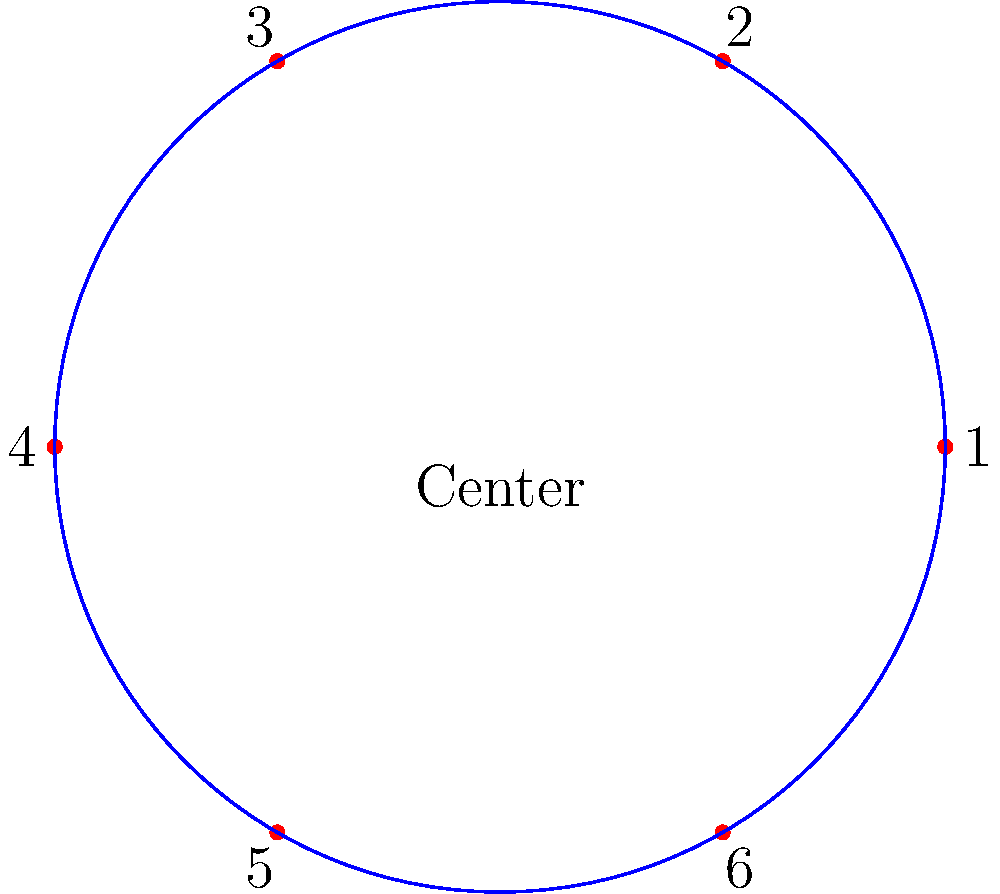At MesoAmerica FC's home stadium, there's a special VIP section with a circular arrangement of seats. The seating follows a rotational symmetry group of order 6. If you're initially seated in position 1 and the usher applies the group operation twice, which seat will you end up in? Let's approach this step-by-step using group theory concepts:

1) The seating arrangement forms a cyclic group $C_6$ of order 6, represented by the rotational symmetry of a regular hexagon.

2) The group operation here is rotation by $60°$ (or $\frac{1}{6}$ of a full rotation) clockwise.

3) The initial position is seat 1.

4) The usher applies the group operation twice, which means two successive rotations of $60°$ each.

5) In group theory notation, this can be written as $g^2$, where $g$ is the generator of the group (a single $60°$ rotation).

6) Two $60°$ rotations result in a total rotation of $120°$.

7) A $120°$ clockwise rotation from position 1 brings us to position 3.

Therefore, after two applications of the group operation, you will end up in seat 3.
Answer: Seat 3 